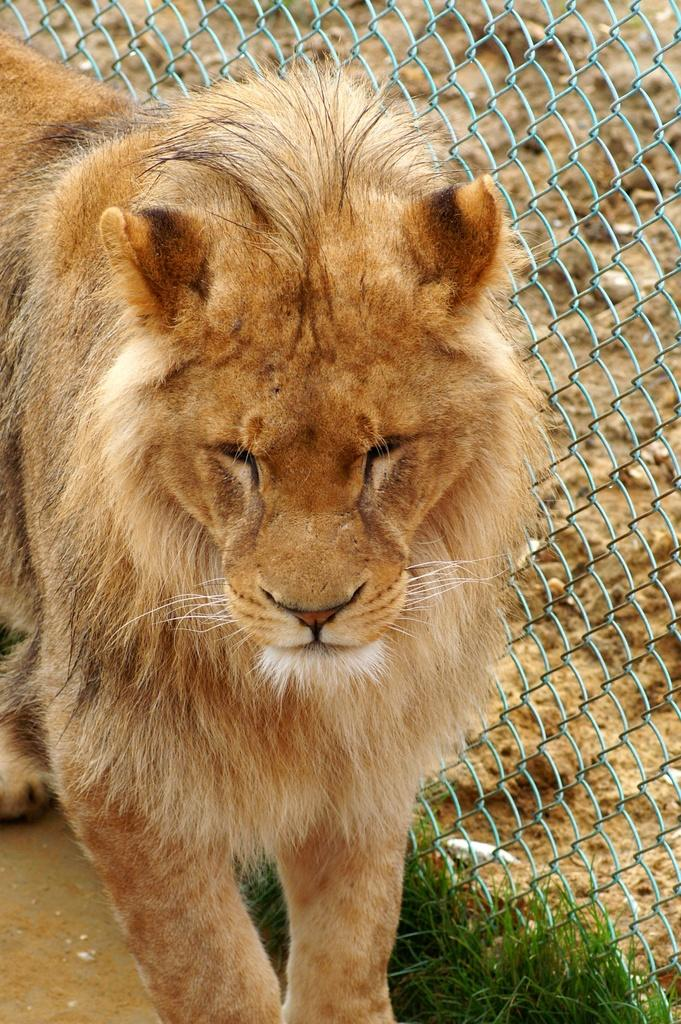What animal is the main subject of the image? There is a lion in the image. What is the lion's position in the image? The lion is standing on the ground. What object is located beside the lion? There is a grill beside the lion. What type of vegetation is present on the ground? There is grass on the ground. What color is the lion's toe in the image? Lions do not have toes like humans, and there is no mention of a lion's toe in the image. 